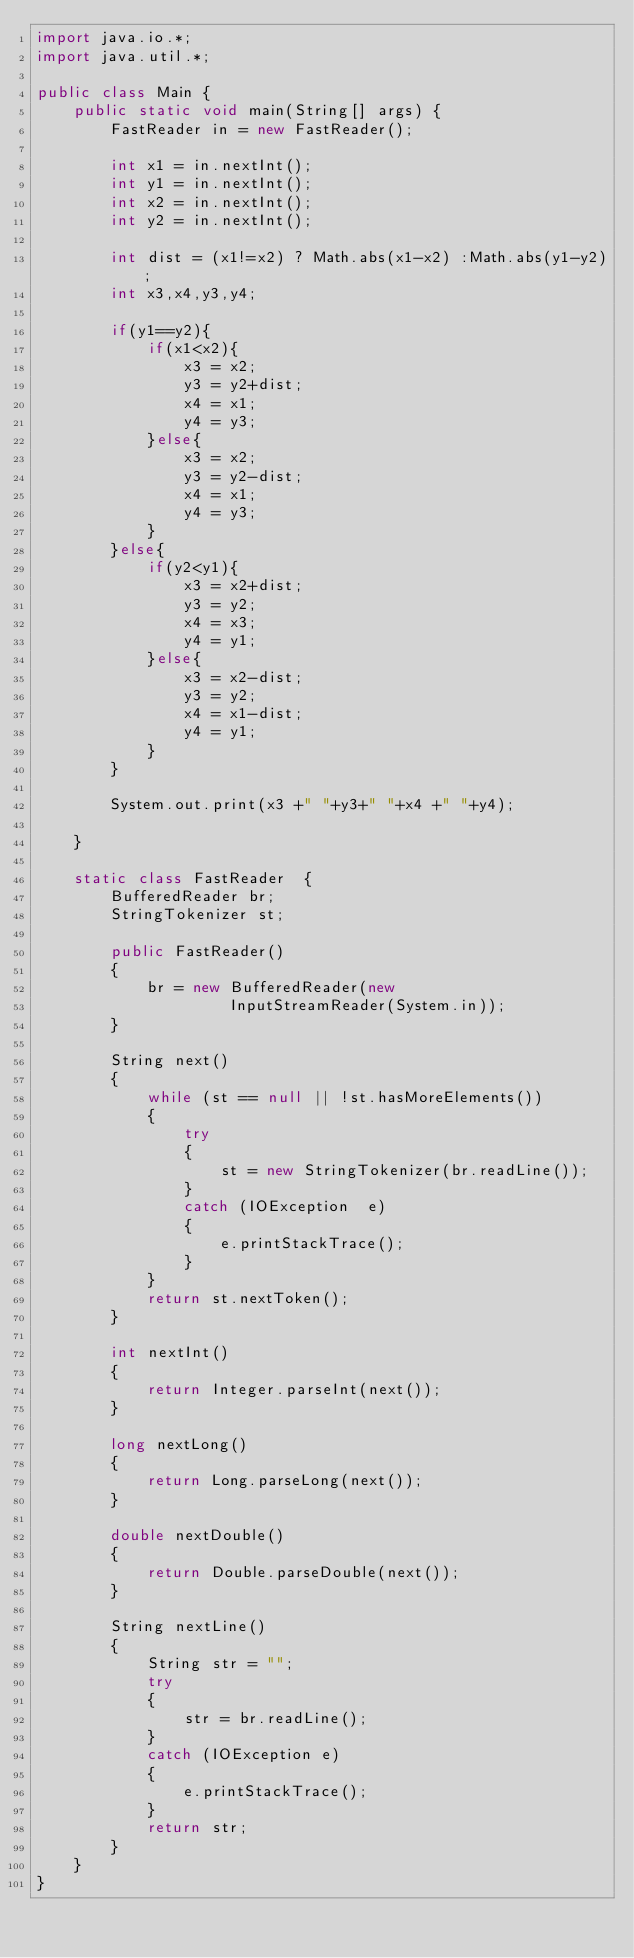<code> <loc_0><loc_0><loc_500><loc_500><_Java_>import java.io.*;
import java.util.*;

public class Main {
    public static void main(String[] args) {
        FastReader in = new FastReader();
        
		int x1 = in.nextInt();
		int y1 = in.nextInt();
		int x2 = in.nextInt();
		int y2 = in.nextInt();
		
		int dist = (x1!=x2) ? Math.abs(x1-x2) :Math.abs(y1-y2);
		int x3,x4,y3,y4;
		
		if(y1==y2){
			if(x1<x2){
				x3 = x2;
				y3 = y2+dist;
				x4 = x1;
				y4 = y3;
			}else{
				x3 = x2;
				y3 = y2-dist;
				x4 = x1;
				y4 = y3;
			}
		}else{
			if(y2<y1){
				x3 = x2+dist;
				y3 = y2;
				x4 = x3;
				y4 = y1;
			}else{
				x3 = x2-dist;
				y3 = y2;
				x4 = x1-dist;
				y4 = y1;
			}
		}
        
		System.out.print(x3 +" "+y3+" "+x4 +" "+y4);

    }
    
    static class FastReader  {
        BufferedReader br;
        StringTokenizer st;
 
        public FastReader()
        {
            br = new BufferedReader(new
                     InputStreamReader(System.in));
        }
 
        String next()
        {
            while (st == null || !st.hasMoreElements())
            {
                try
                {
                    st = new StringTokenizer(br.readLine());
                }
                catch (IOException  e)
                {
                    e.printStackTrace();
                }
            }
            return st.nextToken();
        }
 
        int nextInt()
        {
            return Integer.parseInt(next());
        }
 
        long nextLong()
        {
            return Long.parseLong(next());
        }
 
        double nextDouble()
        {
            return Double.parseDouble(next());
        }
 
        String nextLine()
        {
            String str = "";
            try
            {
                str = br.readLine();
            }
            catch (IOException e)
            {
                e.printStackTrace();
            }
            return str;
        }
    }
}
</code> 